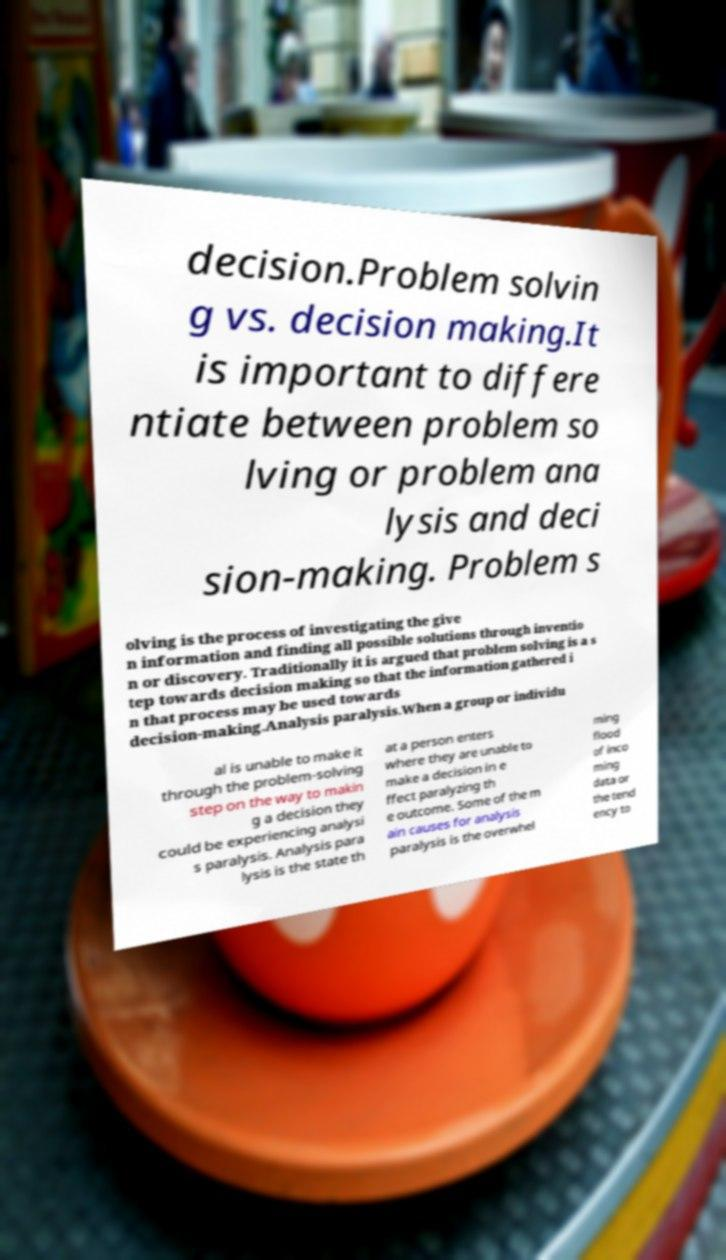Could you assist in decoding the text presented in this image and type it out clearly? decision.Problem solvin g vs. decision making.It is important to differe ntiate between problem so lving or problem ana lysis and deci sion-making. Problem s olving is the process of investigating the give n information and finding all possible solutions through inventio n or discovery. Traditionally it is argued that problem solving is a s tep towards decision making so that the information gathered i n that process may be used towards decision-making.Analysis paralysis.When a group or individu al is unable to make it through the problem-solving step on the way to makin g a decision they could be experiencing analysi s paralysis. Analysis para lysis is the state th at a person enters where they are unable to make a decision in e ffect paralyzing th e outcome. Some of the m ain causes for analysis paralysis is the overwhel ming flood of inco ming data or the tend ency to 